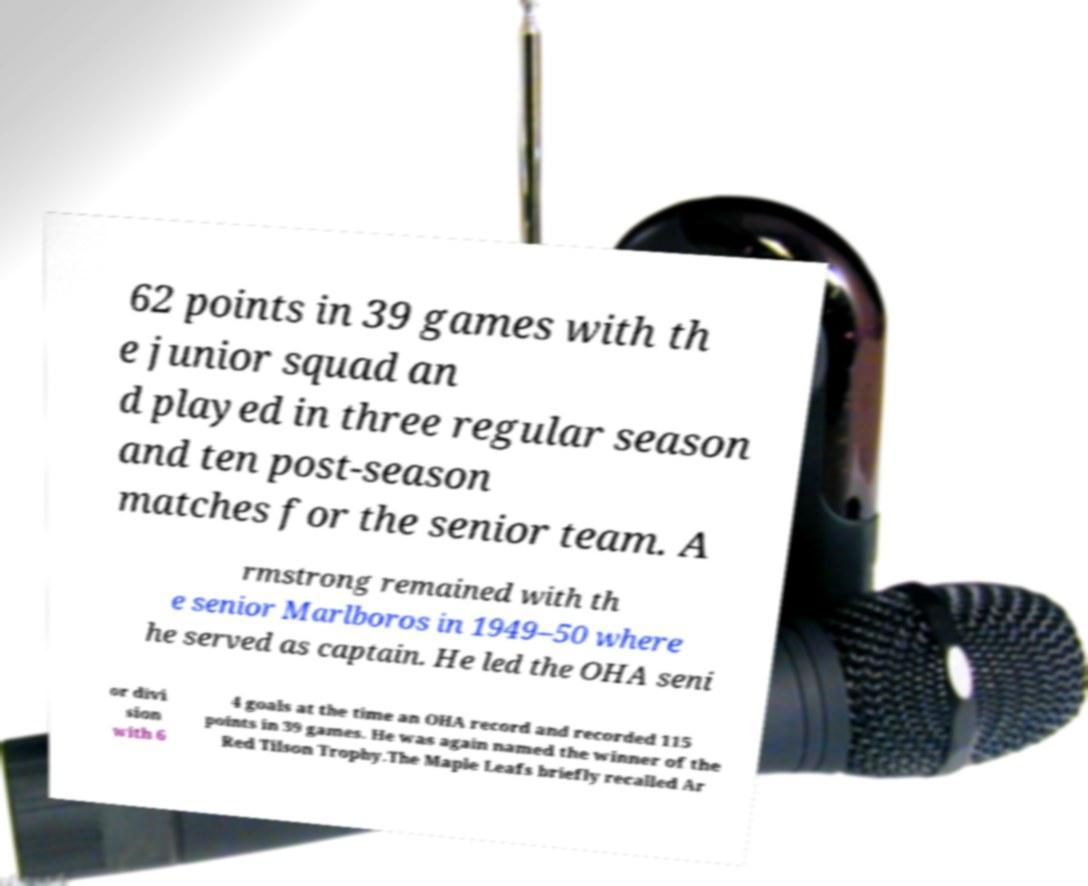For documentation purposes, I need the text within this image transcribed. Could you provide that? 62 points in 39 games with th e junior squad an d played in three regular season and ten post-season matches for the senior team. A rmstrong remained with th e senior Marlboros in 1949–50 where he served as captain. He led the OHA seni or divi sion with 6 4 goals at the time an OHA record and recorded 115 points in 39 games. He was again named the winner of the Red Tilson Trophy.The Maple Leafs briefly recalled Ar 